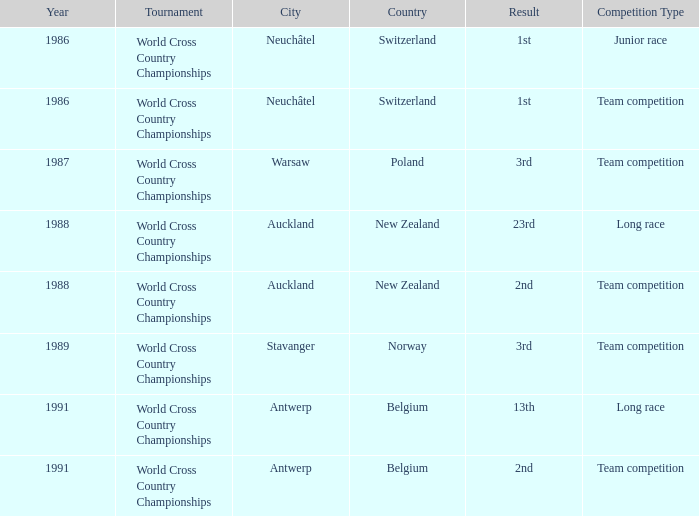Could you parse the entire table as a dict? {'header': ['Year', 'Tournament', 'City', 'Country', 'Result', 'Competition Type'], 'rows': [['1986', 'World Cross Country Championships', 'Neuchâtel', 'Switzerland', '1st', 'Junior race'], ['1986', 'World Cross Country Championships', 'Neuchâtel', 'Switzerland', '1st', 'Team competition'], ['1987', 'World Cross Country Championships', 'Warsaw', 'Poland', '3rd', 'Team competition'], ['1988', 'World Cross Country Championships', 'Auckland', 'New Zealand', '23rd', 'Long race'], ['1988', 'World Cross Country Championships', 'Auckland', 'New Zealand', '2nd', 'Team competition'], ['1989', 'World Cross Country Championships', 'Stavanger', 'Norway', '3rd', 'Team competition'], ['1991', 'World Cross Country Championships', 'Antwerp', 'Belgium', '13th', 'Long race'], ['1991', 'World Cross Country Championships', 'Antwerp', 'Belgium', '2nd', 'Team competition']]} Which venue led to a result of 23rd? Auckland , New Zealand. 